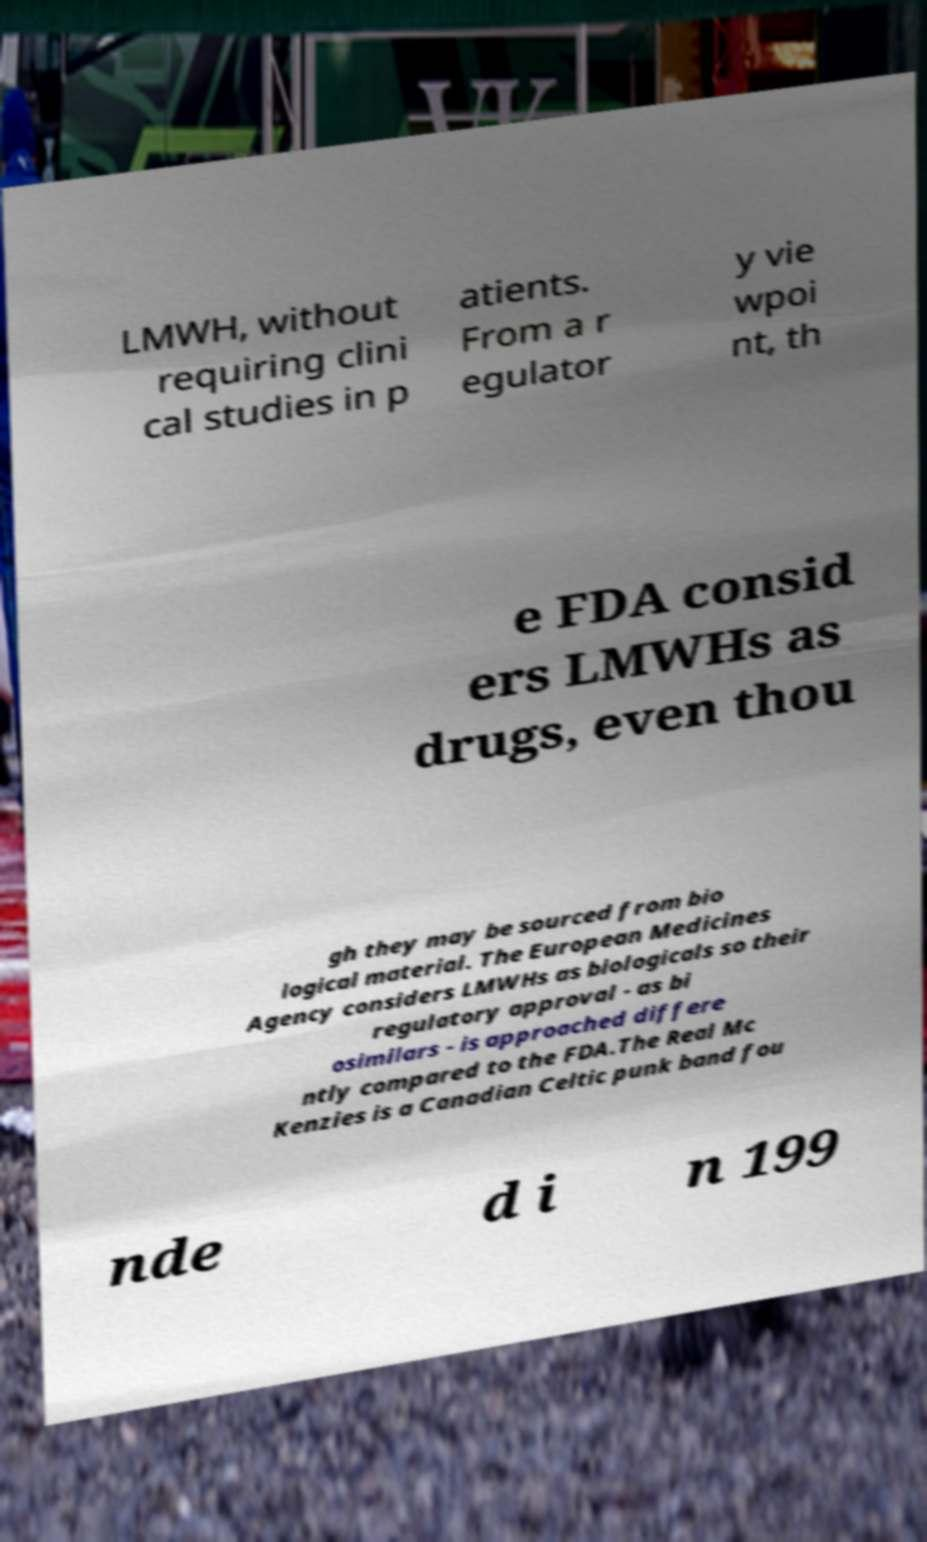Please read and relay the text visible in this image. What does it say? LMWH, without requiring clini cal studies in p atients. From a r egulator y vie wpoi nt, th e FDA consid ers LMWHs as drugs, even thou gh they may be sourced from bio logical material. The European Medicines Agency considers LMWHs as biologicals so their regulatory approval - as bi osimilars - is approached differe ntly compared to the FDA.The Real Mc Kenzies is a Canadian Celtic punk band fou nde d i n 199 